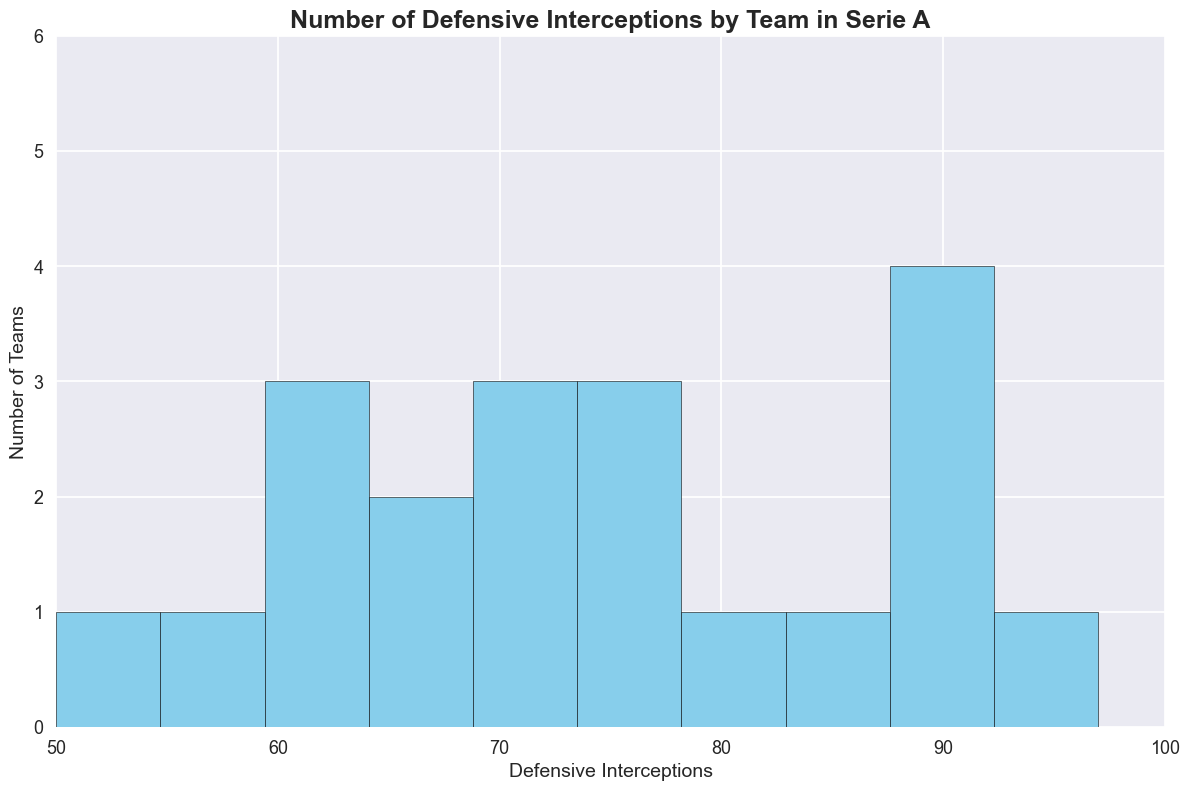What's the most common range of defensive interceptions among teams? The histogram shows the frequency distribution of defensive interceptions. By counting the number of teams in each bin, it's clear that the 70-80 range has the most teams, typically indicating the most common range.
Answer: 70-80 What's the difference between the highest and the lowest number of defensive interceptions? The highest bar represents Juventus with 97 interceptions and the lowest bar represents Salernitana with 50 interceptions. So, the difference is calculated as 97 - 50.
Answer: 47 How many teams have defensive interceptions greater than or equal to 90? Looking at the rightmost bins of the histogram, we see bars for the ranges 90-100. The count of teams in these bins gives us the answer. There are Juventus, AC Milan, and Napoli, making it 3 teams.
Answer: 3 Are there more teams with fewer than 70 defensive interceptions or more? Count the number of teams in the 50-60 and 60-70 bins, then compare that with the count of teams in other bins. Teams with fewer than 70 interceptions are in the ranges of 50-70, add their counts to get the total, then compare to the total number of teams.
Answer: More than 70 What's the range with the highest number of teams, and how many teams are in that range? By examining the heights of the bars in the histogram, we identify the tallest bar and then check the label of that bar’s range. The tallest bar is for the range 70-80, indicating the highest number of teams.
Answer: 6 Which range has the fewest number of teams, and how many teams are in that range? By inspecting the shortest bars in the histogram, we identify the bins with the lowest values. The shortest bar(s) represent one team in a given range. The 90-100 range has only 1 team.
Answer: The 90-100 range, 1 team How many teams have defensive interceptions in the range 80-90? By looking at the histogram and counting the bars for each bin in the 80-90 range, we find there are 85, 88, and 89, making up three teams.
Answer: 3 What's the average number of defensive interceptions for all teams? Sum all the data values (97+85+90+92+88+74+80+78+75+89+70+65+66+71+63+69+62+60+55+50) and divide by the number of teams, which is 20. The total sum is 1500, so 1500/20.
Answer: 75 